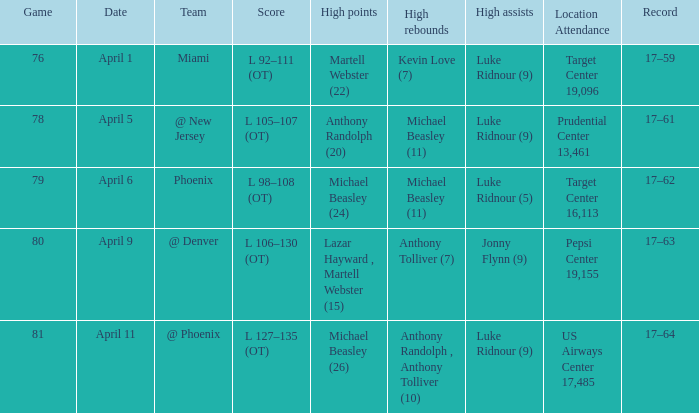In how many different games did Luke Ridnour (5) did the most high assists? 1.0. Could you parse the entire table? {'header': ['Game', 'Date', 'Team', 'Score', 'High points', 'High rebounds', 'High assists', 'Location Attendance', 'Record'], 'rows': [['76', 'April 1', 'Miami', 'L 92–111 (OT)', 'Martell Webster (22)', 'Kevin Love (7)', 'Luke Ridnour (9)', 'Target Center 19,096', '17–59'], ['78', 'April 5', '@ New Jersey', 'L 105–107 (OT)', 'Anthony Randolph (20)', 'Michael Beasley (11)', 'Luke Ridnour (9)', 'Prudential Center 13,461', '17–61'], ['79', 'April 6', 'Phoenix', 'L 98–108 (OT)', 'Michael Beasley (24)', 'Michael Beasley (11)', 'Luke Ridnour (5)', 'Target Center 16,113', '17–62'], ['80', 'April 9', '@ Denver', 'L 106–130 (OT)', 'Lazar Hayward , Martell Webster (15)', 'Anthony Tolliver (7)', 'Jonny Flynn (9)', 'Pepsi Center 19,155', '17–63'], ['81', 'April 11', '@ Phoenix', 'L 127–135 (OT)', 'Michael Beasley (26)', 'Anthony Randolph , Anthony Tolliver (10)', 'Luke Ridnour (9)', 'US Airways Center 17,485', '17–64']]} 